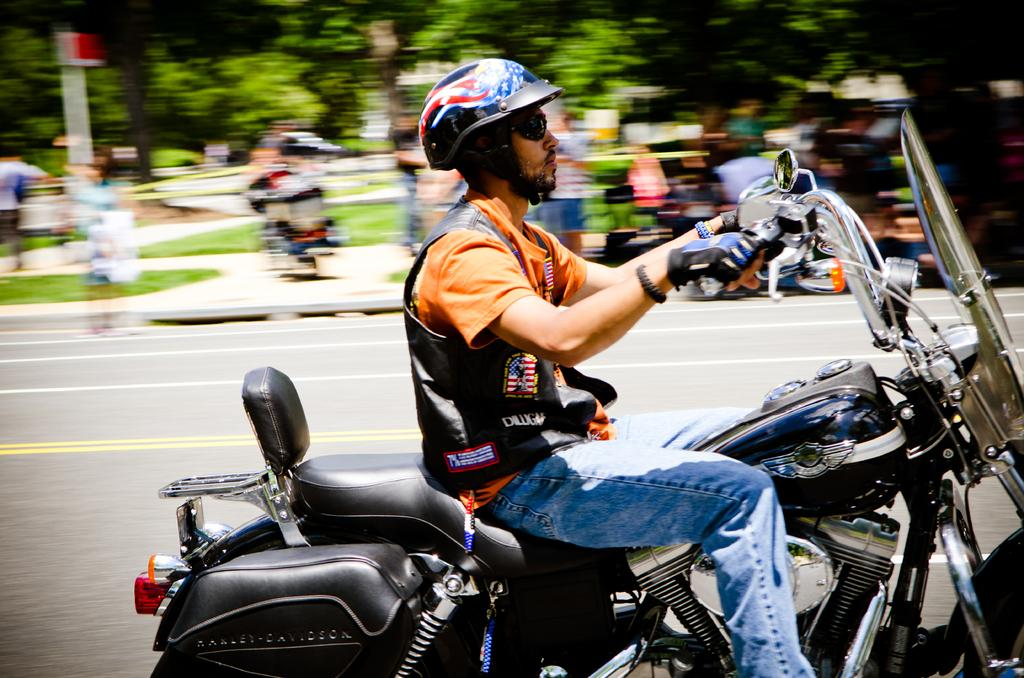What is the man in the image doing? The man is riding a motorcycle in the image. What safety precaution is the man taking while riding the motorcycle? The man is wearing a helmet while riding the motorcycle. What type of eyewear is the man wearing? The man is wearing spectacles in the image. What can be seen in the background of the image? There are trees in the background of the image. What type of surface is visible in the image? There is a road visible in the image. What type of yarn is the man using to knit a scarf while riding the motorcycle? There is no yarn or knitting activity present in the image; the man is simply riding a motorcycle. 